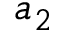<formula> <loc_0><loc_0><loc_500><loc_500>a _ { 2 }</formula> 